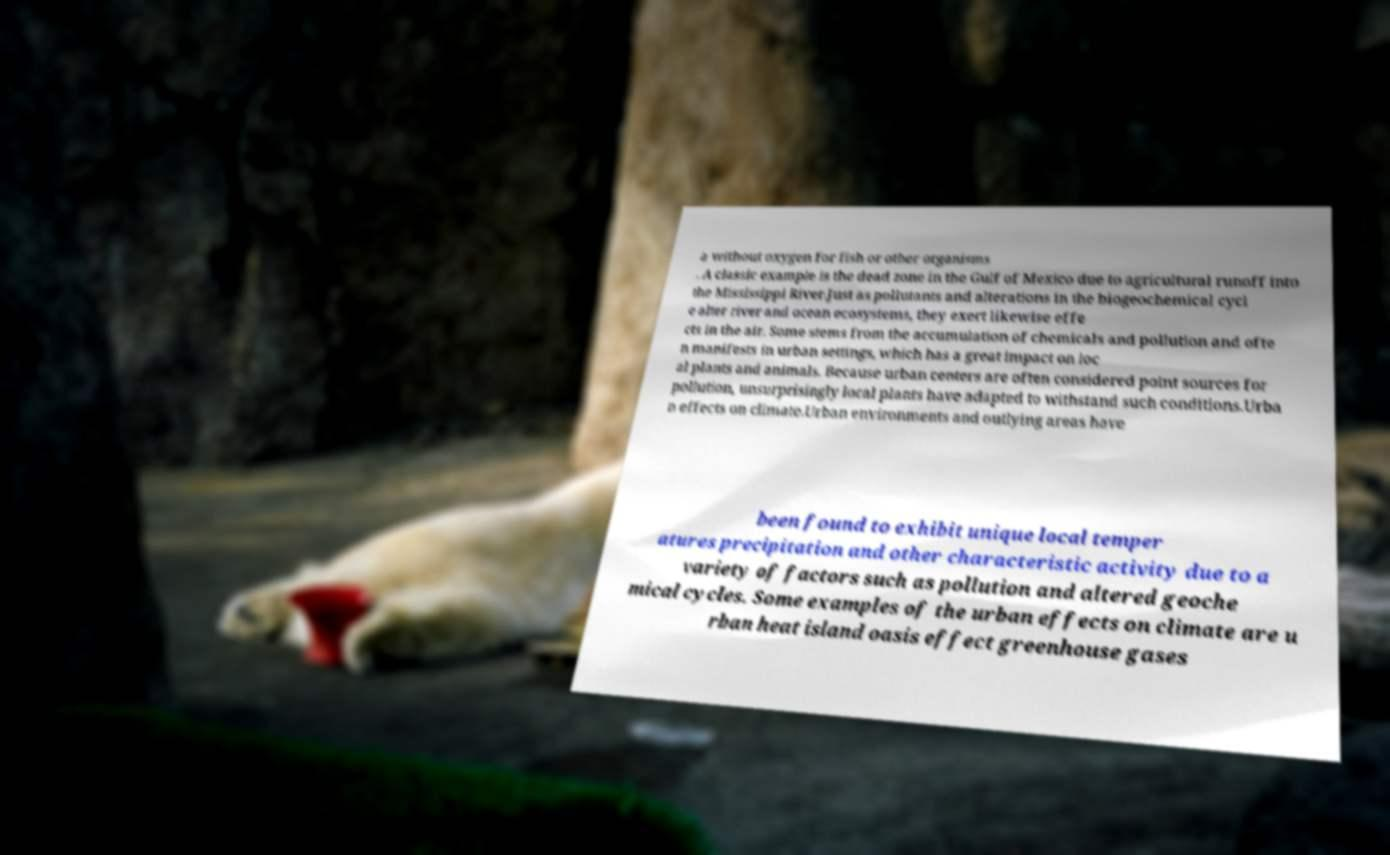For documentation purposes, I need the text within this image transcribed. Could you provide that? a without oxygen for fish or other organisms . A classic example is the dead zone in the Gulf of Mexico due to agricultural runoff into the Mississippi River.Just as pollutants and alterations in the biogeochemical cycl e alter river and ocean ecosystems, they exert likewise effe cts in the air. Some stems from the accumulation of chemicals and pollution and ofte n manifests in urban settings, which has a great impact on loc al plants and animals. Because urban centers are often considered point sources for pollution, unsurprisingly local plants have adapted to withstand such conditions.Urba n effects on climate.Urban environments and outlying areas have been found to exhibit unique local temper atures precipitation and other characteristic activity due to a variety of factors such as pollution and altered geoche mical cycles. Some examples of the urban effects on climate are u rban heat island oasis effect greenhouse gases 